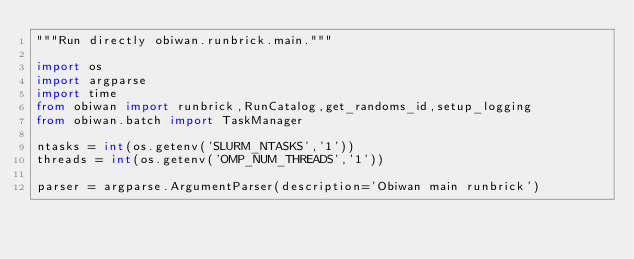<code> <loc_0><loc_0><loc_500><loc_500><_Python_>"""Run directly obiwan.runbrick.main."""

import os
import argparse
import time
from obiwan import runbrick,RunCatalog,get_randoms_id,setup_logging
from obiwan.batch import TaskManager

ntasks = int(os.getenv('SLURM_NTASKS','1'))
threads = int(os.getenv('OMP_NUM_THREADS','1'))

parser = argparse.ArgumentParser(description='Obiwan main runbrick')</code> 